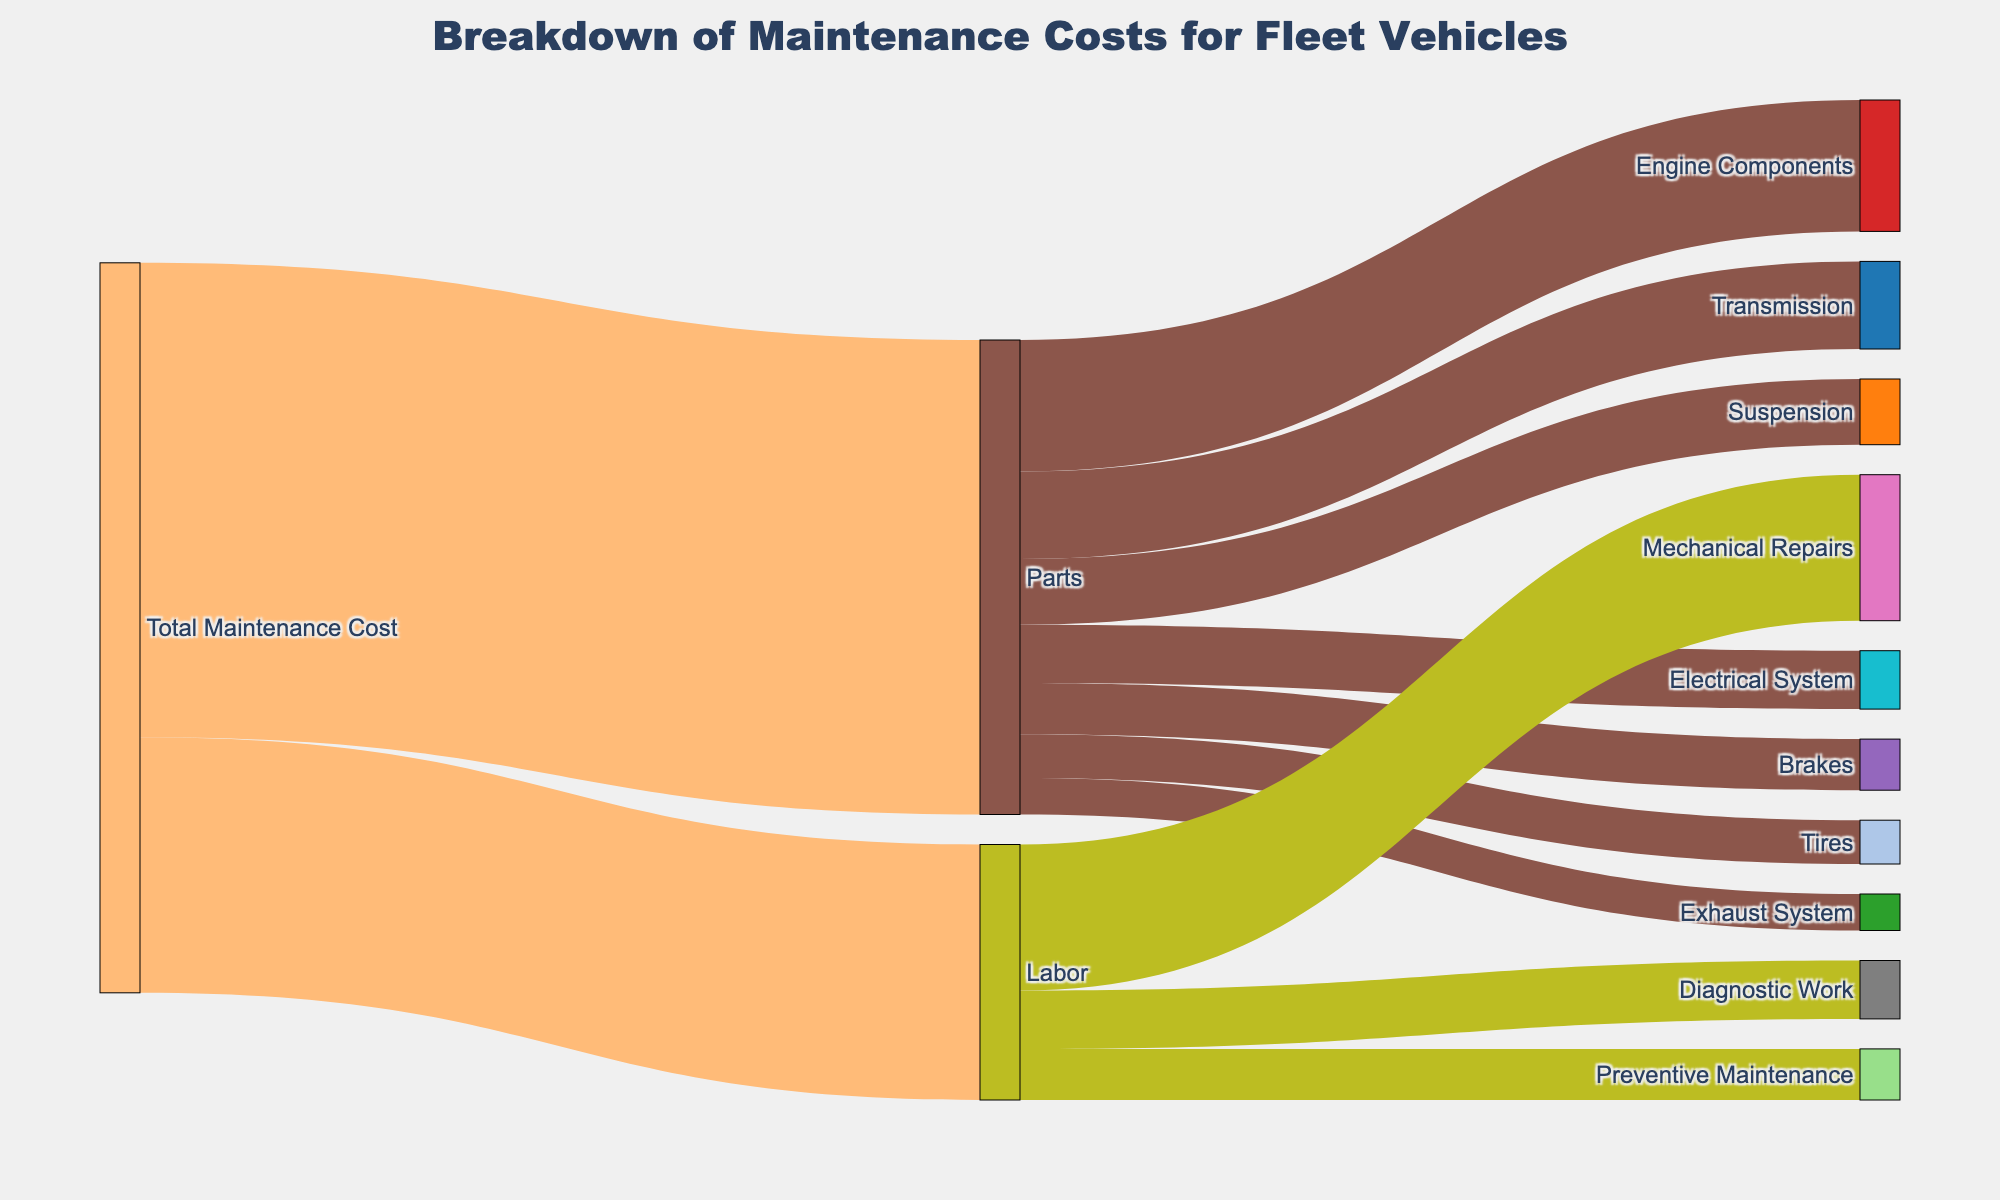What's the title of the figure? The title is displayed prominently at the top of the figure.
Answer: Breakdown of Maintenance Costs for Fleet Vehicles What are the two main categories of maintenance costs represented in the diagram? The two main categories branch out from "Total Maintenance Cost" to "Parts" and "Labor".
Answer: Parts and Labor Which component under Parts has the highest cost? The "Parts" category has various components, and the thickness of the link from "Parts" to each component indicates the cost. The thickest link is to "Engine Components".
Answer: Engine Components What is the total cost associated with Labor? The total cost for Labor is shown in the link from "Total Maintenance Cost" to "Labor". The value is labeled next to this link.
Answer: 35000 How much more is spent on Mechanical Repairs compared to Diagnostic Work? The cost for Mechanical Repairs is 20000 and for Diagnostic Work is 8000. Subtract the latter from the former.
Answer: 12000 What percentage of the Total Maintenance Cost is attributed to Electrical System parts? Calculate the fraction of the Electrical System cost (8000) over the Total Maintenance Cost (100000), then multiply by 100 to get the percentage. \( \frac{8000}{100000} \times 100 \)
Answer: 8% Compare the costs of Preventive Maintenance and Exhaust System parts. Which one is higher and by how much? Preventive Maintenance costs 7000, while Exhaust System costs 5000. Subtract Exhaust System from Preventive Maintenance.
Answer: Preventive Maintenance is higher by 2000 What is the combined cost of Engine Components and Transmission parts? Sum the costs of Engine Components (18000) and Transmission (12000).
Answer: 30000 Which has more cost: Brakes or Tires? Compare the values linked from "Parts" to "Brakes" (7000) and "Tires" (6000).
Answer: Brakes What is the least costly item under the category of Parts? Among all links branching from "Parts", the one with the smallest value indicates the least cost. Exhaust System is the smallest at 5000.
Answer: Exhaust System 